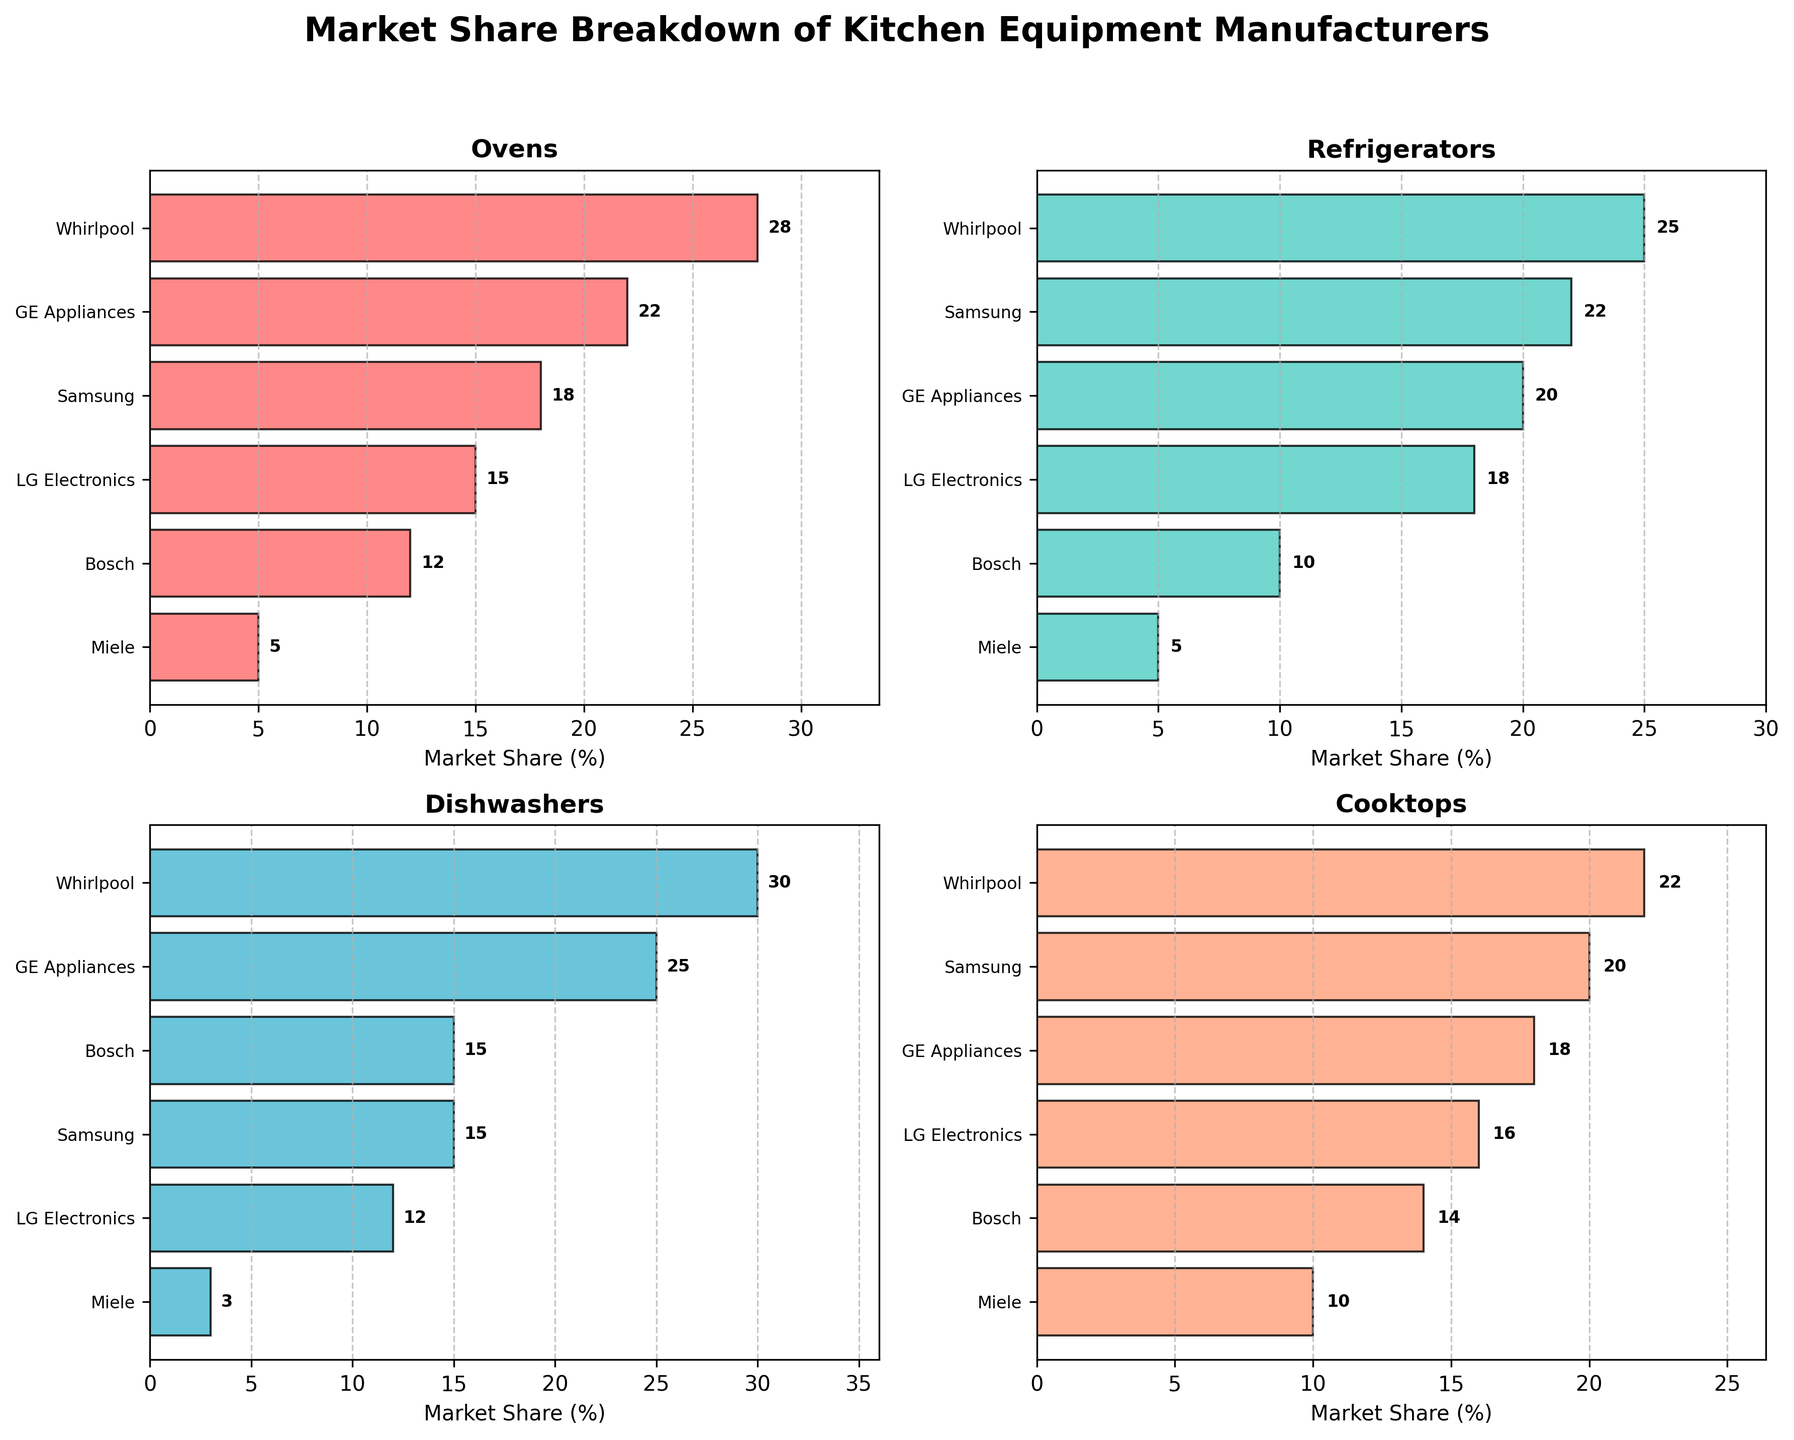What is the title of the figure? The title is usually located at the top center of the figure. In this case, it reads "Market Share Breakdown of Kitchen Equipment Manufacturers".
Answer: Market Share Breakdown of Kitchen Equipment Manufacturers What is the market share of Whirlpool in refrigerators? By looking at the bar representing Whirlpool in the 'Refrigerators' subplot, we can see the exact value given next to the bar.
Answer: 25 Which manufacturer has the least market share in dishwashers? In the 'Dishwashers' subplot, we can identify the shortest bar, which represents the lowest value. Miele has the smallest bar in this category.
Answer: Miele Is Samsung’s market share in cooktops higher than in ovens? By comparing the lengths of the Samsung bars in the 'Cooktops' and 'Ovens' subplots, we notice that the cooktop bar is longer.
Answer: Yes What is the difference in market share between GE Appliances and LG Electronics in ovens? In the 'Ovens' subplot, we look at the values for GE Appliances and LG Electronics and subtract the latter from the former (22 - 15).
Answer: 7 Which manufacturer has the largest range (difference between the highest and lowest values) across all product segments? We calculate the range for each manufacturer across the four segments. Whirlpool (30-22=8), GE Appliances (25-18=7), Samsung (22-15=7), LG Electronics (18-12=6), Bosch (15-10=5), Miele (10-3=7). Whirlpool has the largest range.
Answer: Whirlpool On average, what is the market share of Bosch across all segments? Add Bosch's market shares (12+10+15+14) and divide by the number of segments (4). (12+10+15+14) / 4 = 12.75.
Answer: 12.75 In which category does LG Electronics have the smallest market share? By looking at the bars representing LG Electronics in each of the four subplots, we identify the smallest bar in 'Dishwashers'.
Answer: Dishwashers How does Miele’s market share in cooktops compare to its market share in ovens? We compare the lengths of Miele's bars in the 'Cooktops' and 'Ovens' subplots. Miele has a smaller share in ovens (5) compared to cooktops (10).
Answer: Miele’s share in cooktops is higher 